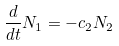<formula> <loc_0><loc_0><loc_500><loc_500>\frac { d } { d t } N _ { 1 } = - c _ { 2 } N _ { 2 }</formula> 